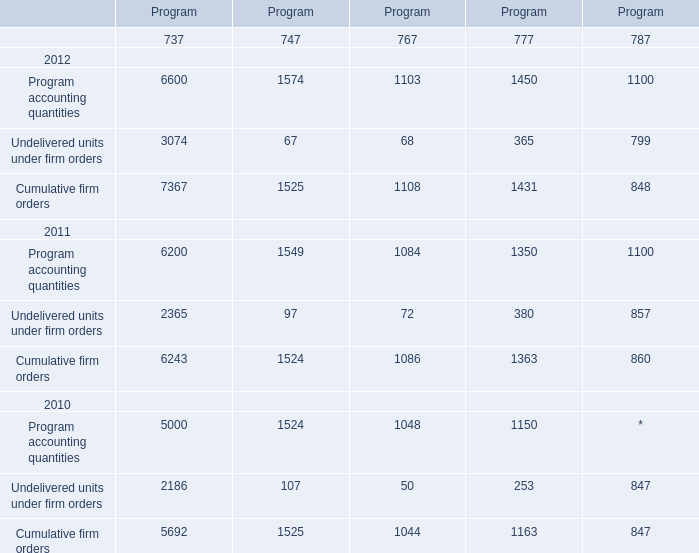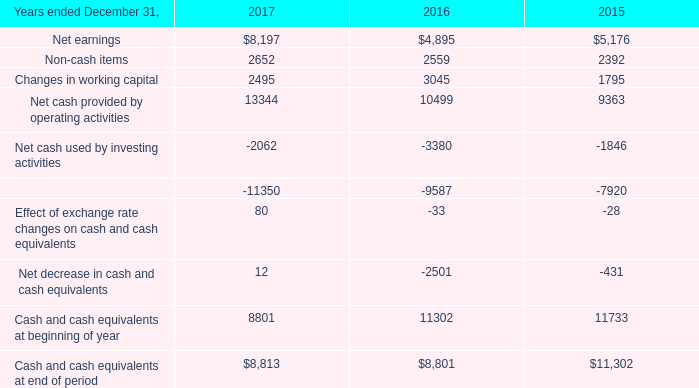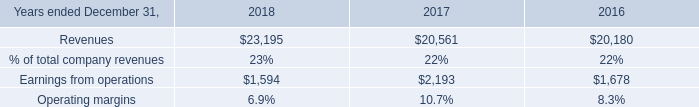What's the sum of Net cash used by financing activities of 2015, Program accounting quantities 2011 of Program.4, and Undelivered units under firm orders 2011 of Program ? 
Computations: ((7920.0 + 1100.0) + 2365.0)
Answer: 11385.0. 